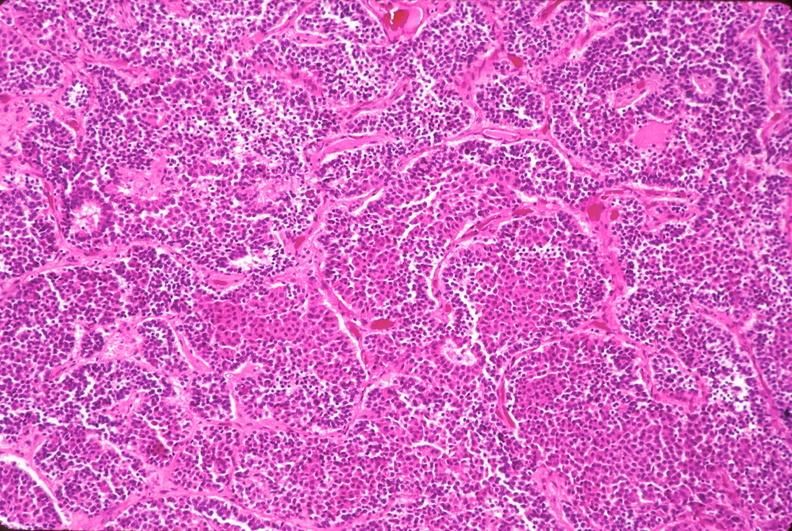does this image show pituitary, chromaphobe adenoma?
Answer the question using a single word or phrase. Yes 